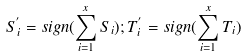Convert formula to latex. <formula><loc_0><loc_0><loc_500><loc_500>S _ { i } ^ { ^ { \prime } } = s i g n ( \sum _ { i = 1 } ^ { x } S _ { i } ) ; T _ { i } ^ { ^ { \prime } } = s i g n ( \sum _ { i = 1 } ^ { x } T _ { i } )</formula> 